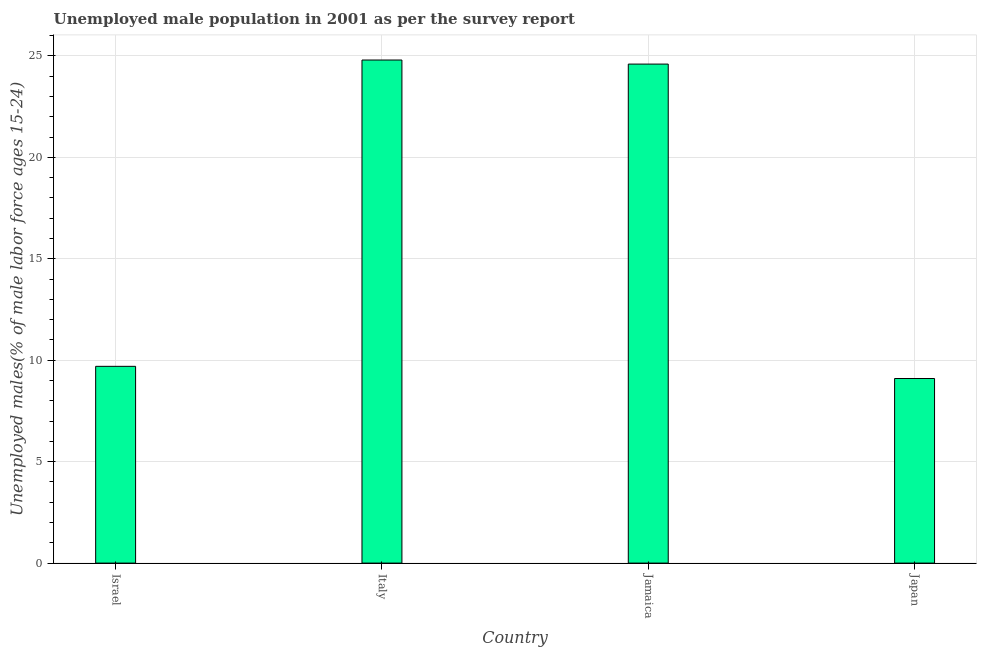Does the graph contain any zero values?
Your answer should be very brief. No. What is the title of the graph?
Your answer should be very brief. Unemployed male population in 2001 as per the survey report. What is the label or title of the Y-axis?
Give a very brief answer. Unemployed males(% of male labor force ages 15-24). What is the unemployed male youth in Japan?
Provide a succinct answer. 9.1. Across all countries, what is the maximum unemployed male youth?
Offer a very short reply. 24.8. Across all countries, what is the minimum unemployed male youth?
Offer a terse response. 9.1. What is the sum of the unemployed male youth?
Your answer should be very brief. 68.2. What is the difference between the unemployed male youth in Israel and Jamaica?
Provide a short and direct response. -14.9. What is the average unemployed male youth per country?
Offer a terse response. 17.05. What is the median unemployed male youth?
Keep it short and to the point. 17.15. What is the ratio of the unemployed male youth in Italy to that in Jamaica?
Keep it short and to the point. 1.01. Is the difference between the unemployed male youth in Israel and Japan greater than the difference between any two countries?
Your response must be concise. No. Is the sum of the unemployed male youth in Israel and Japan greater than the maximum unemployed male youth across all countries?
Give a very brief answer. No. What is the difference between the highest and the lowest unemployed male youth?
Your answer should be very brief. 15.7. In how many countries, is the unemployed male youth greater than the average unemployed male youth taken over all countries?
Make the answer very short. 2. Are the values on the major ticks of Y-axis written in scientific E-notation?
Your response must be concise. No. What is the Unemployed males(% of male labor force ages 15-24) of Israel?
Keep it short and to the point. 9.7. What is the Unemployed males(% of male labor force ages 15-24) in Italy?
Offer a very short reply. 24.8. What is the Unemployed males(% of male labor force ages 15-24) of Jamaica?
Offer a terse response. 24.6. What is the Unemployed males(% of male labor force ages 15-24) in Japan?
Offer a terse response. 9.1. What is the difference between the Unemployed males(% of male labor force ages 15-24) in Israel and Italy?
Your response must be concise. -15.1. What is the difference between the Unemployed males(% of male labor force ages 15-24) in Israel and Jamaica?
Your answer should be very brief. -14.9. What is the difference between the Unemployed males(% of male labor force ages 15-24) in Italy and Japan?
Keep it short and to the point. 15.7. What is the ratio of the Unemployed males(% of male labor force ages 15-24) in Israel to that in Italy?
Provide a succinct answer. 0.39. What is the ratio of the Unemployed males(% of male labor force ages 15-24) in Israel to that in Jamaica?
Give a very brief answer. 0.39. What is the ratio of the Unemployed males(% of male labor force ages 15-24) in Israel to that in Japan?
Ensure brevity in your answer.  1.07. What is the ratio of the Unemployed males(% of male labor force ages 15-24) in Italy to that in Jamaica?
Ensure brevity in your answer.  1.01. What is the ratio of the Unemployed males(% of male labor force ages 15-24) in Italy to that in Japan?
Ensure brevity in your answer.  2.73. What is the ratio of the Unemployed males(% of male labor force ages 15-24) in Jamaica to that in Japan?
Ensure brevity in your answer.  2.7. 